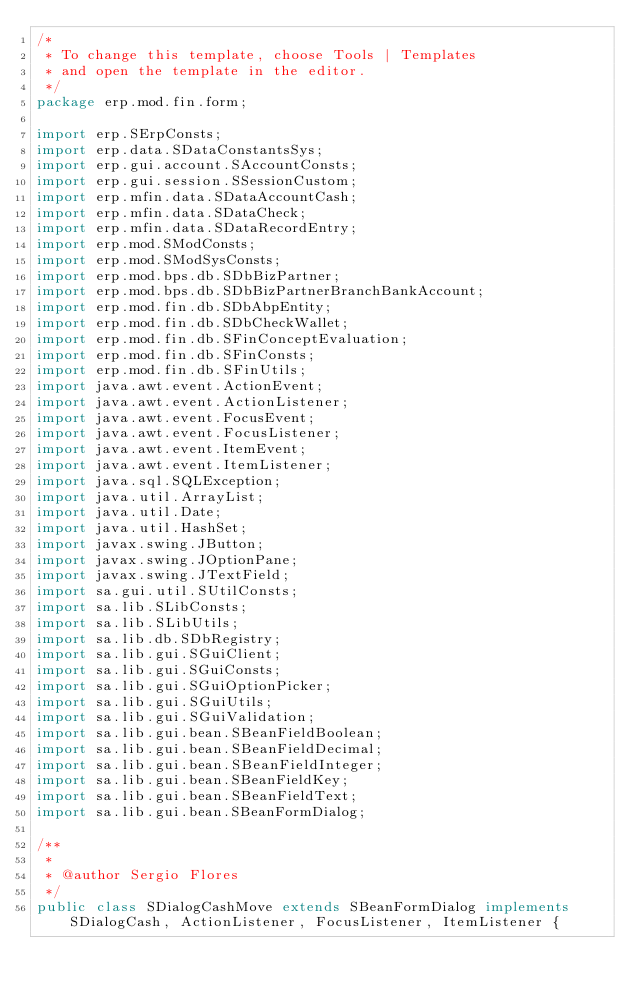Convert code to text. <code><loc_0><loc_0><loc_500><loc_500><_Java_>/*
 * To change this template, choose Tools | Templates
 * and open the template in the editor.
 */
package erp.mod.fin.form;

import erp.SErpConsts;
import erp.data.SDataConstantsSys;
import erp.gui.account.SAccountConsts;
import erp.gui.session.SSessionCustom;
import erp.mfin.data.SDataAccountCash;
import erp.mfin.data.SDataCheck;
import erp.mfin.data.SDataRecordEntry;
import erp.mod.SModConsts;
import erp.mod.SModSysConsts;
import erp.mod.bps.db.SDbBizPartner;
import erp.mod.bps.db.SDbBizPartnerBranchBankAccount;
import erp.mod.fin.db.SDbAbpEntity;
import erp.mod.fin.db.SDbCheckWallet;
import erp.mod.fin.db.SFinConceptEvaluation;
import erp.mod.fin.db.SFinConsts;
import erp.mod.fin.db.SFinUtils;
import java.awt.event.ActionEvent;
import java.awt.event.ActionListener;
import java.awt.event.FocusEvent;
import java.awt.event.FocusListener;
import java.awt.event.ItemEvent;
import java.awt.event.ItemListener;
import java.sql.SQLException;
import java.util.ArrayList;
import java.util.Date;
import java.util.HashSet;
import javax.swing.JButton;
import javax.swing.JOptionPane;
import javax.swing.JTextField;
import sa.gui.util.SUtilConsts;
import sa.lib.SLibConsts;
import sa.lib.SLibUtils;
import sa.lib.db.SDbRegistry;
import sa.lib.gui.SGuiClient;
import sa.lib.gui.SGuiConsts;
import sa.lib.gui.SGuiOptionPicker;
import sa.lib.gui.SGuiUtils;
import sa.lib.gui.SGuiValidation;
import sa.lib.gui.bean.SBeanFieldBoolean;
import sa.lib.gui.bean.SBeanFieldDecimal;
import sa.lib.gui.bean.SBeanFieldInteger;
import sa.lib.gui.bean.SBeanFieldKey;
import sa.lib.gui.bean.SBeanFieldText;
import sa.lib.gui.bean.SBeanFormDialog;

/**
 *
 * @author Sergio Flores
 */
public class SDialogCashMove extends SBeanFormDialog implements SDialogCash, ActionListener, FocusListener, ItemListener {
</code> 